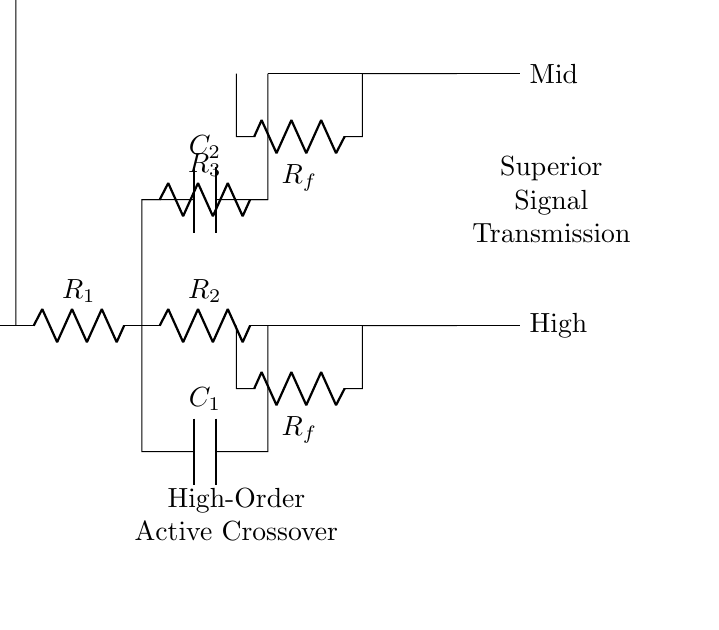What is the input component of the circuit? The input component is represented at the left side of the circuit as "Input," where the signal enters the crossover network.
Answer: Input How many resistors are in the circuit? There are four resistors labeled as R1, R2, R3, and R4, which are visible in the diagram connecting various components.
Answer: Four What type of filters are implemented in the network? The circuit features three types of filters: a high-pass filter (using C1/R2), a mid-range filter (using C2/R3), and a low-pass filter (using C3/R4).
Answer: High-pass, Mid-range, Low-pass What is the purpose of the feedback resistors in the circuit? The feedback resistors (Rf) are used to stabilize the gain of the operational amplifiers, ensuring they operate within suitable limits and prevent distortion.
Answer: Stabilize gain What is the output labeling for the low-pass filter? The output for the low-pass filter is labeled as "Low," indicating the signal directed from that particular filter section of the circuit.
Answer: Low Which capacitor is associated with the mid-range filter? The capacitor associated with the mid-range filter is labeled as C2, and it is connected between the node points of the mid-range section.
Answer: C2 What does the label "Superior Signal Transmission" imply in the context of the circuit? The label suggests that the circuit is designed specifically to enhance the quality and clarity of the audio signal being transmitted through each filter section.
Answer: Enhanced quality 